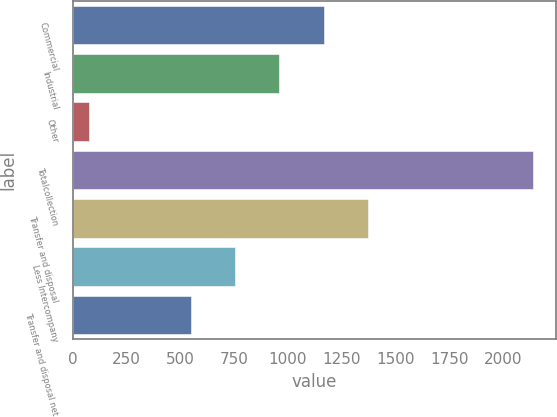<chart> <loc_0><loc_0><loc_500><loc_500><bar_chart><fcel>Commercial<fcel>Industrial<fcel>Other<fcel>Totalcollection<fcel>Transfer and disposal<fcel>Less Intercompany<fcel>Transfer and disposal net<nl><fcel>1167.25<fcel>961<fcel>76.6<fcel>2139.1<fcel>1373.5<fcel>754.75<fcel>548.5<nl></chart> 